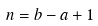Convert formula to latex. <formula><loc_0><loc_0><loc_500><loc_500>n = b - a + 1</formula> 